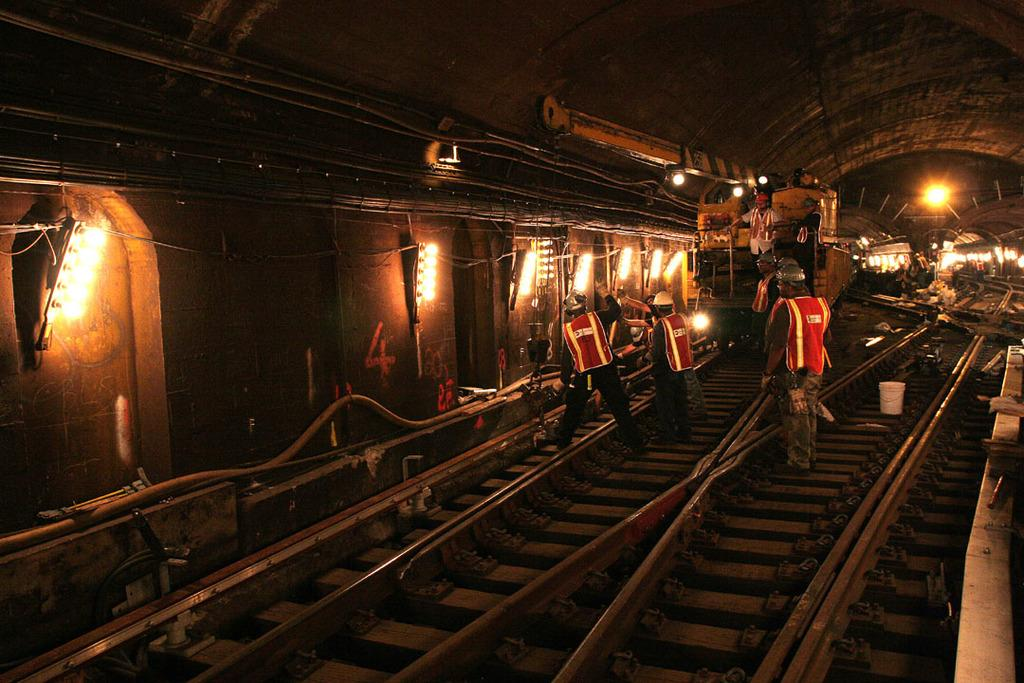How many people are in the image? There are people in the image, but the exact number is not specified. What are the people wearing in the image? The people are wearing safety jackets and helmets in the image. What can be seen in the background of the image? There are lights, pipes, and a wall with text visible in the image. What is at the bottom of the image? There are tracks at the bottom of the image. What type of plant is growing on the tracks in the image? There is no plant growing on the tracks in the image. How can the lights be adjusted in the image? The image does not show any controls or mechanisms for adjusting the lights, so it is not possible to answer this question. 